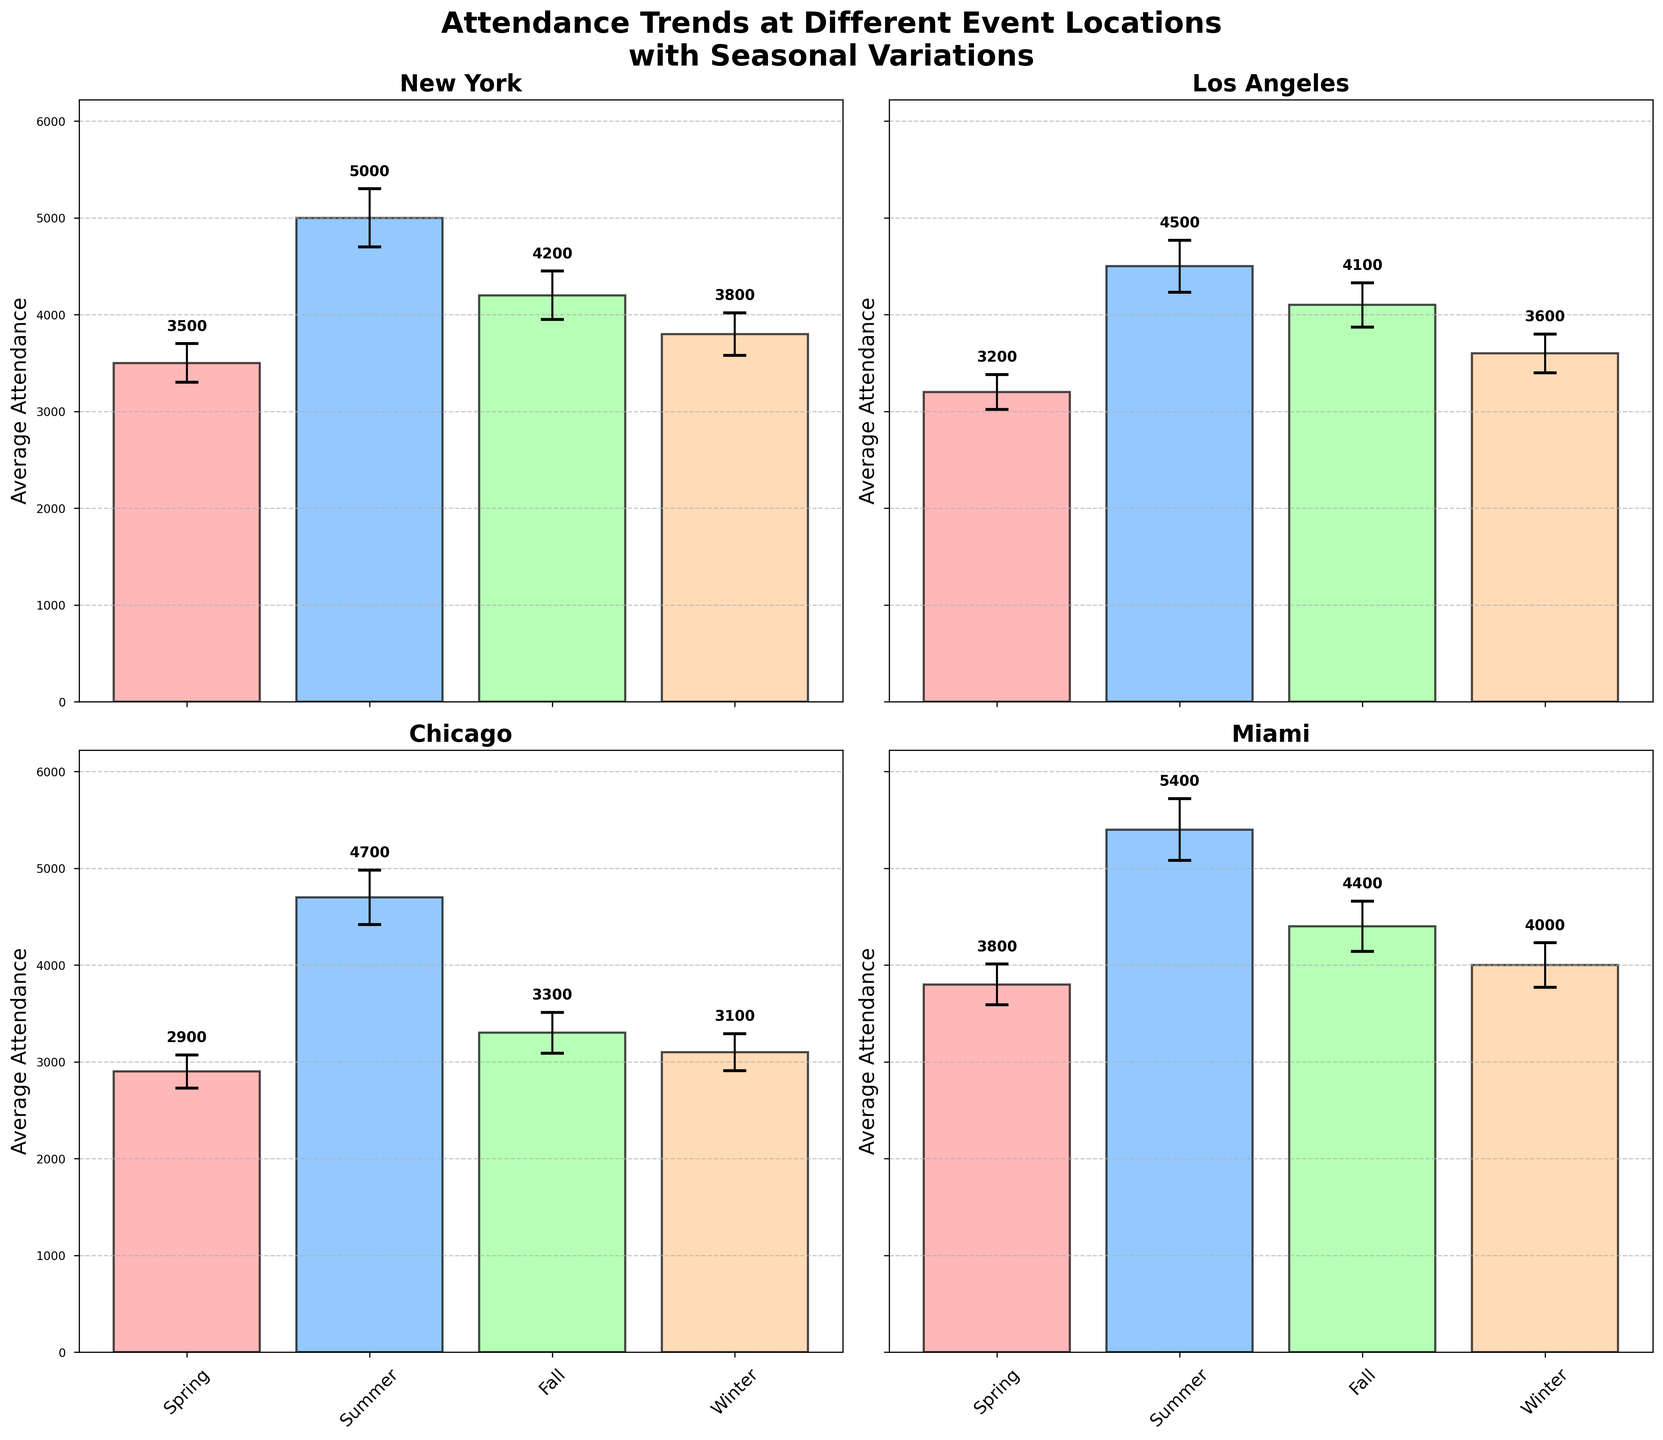What city's attendance is highest in Summer? By looking at the heights of the bars for the Summer season across all cities, Miami has the tallest bar, indicating the highest attendance.
Answer: Miami Which location has the lowest Winter attendance? Comparing the height of the Winter season bars across all subplots, Chicago has the shortest bar.
Answer: Chicago For New York, what is the difference in average attendance between Summer and Winter? The average attendance in Summer is 5000 and in Winter is 3800. The difference is 5000 - 3800 = 1200.
Answer: 1200 How do the error bars for New York in Fall compare with those for Miami in Spring? The error bar for New York in Fall has a standard deviation of 250, while the error bar for Miami in Spring has a standard deviation of 210. Therefore, New York in Fall has wider error bars than Miami in Spring.
Answer: Wider On average, which season generally sees the highest attendance across all cities? By observing the bar heights for each season across all subplots, Summer consistently has the highest bars on average.
Answer: Summer What is the total average attendance for Chicago across all seasons? Sum the average attendance values for Chicago across all seasons: 2900 (Spring) + 4700 (Summer) + 3300 (Fall) + 3100 (Winter) = 14000.
Answer: 14000 What is the range of attendance for Los Angeles in Summer, considering the error bars? The average attendance for Los Angeles in Summer is 4500 with a standard deviation of 270. Thus, the range is from 4500 - 270 to 4500 + 270, which is 4230 to 4770.
Answer: 4230 to 4770 Which city shows the most variation in attendance between different seasons? By visually comparing the differences in bar heights for each city's seasons, New York shows significant variation, especially between Spring and Summer, indicating the most variation.
Answer: New York Is the attendance in Miami for Fall higher or lower than in New York for the same season? The bar representing Fall for Miami is taller than that for New York, indicating Miami has a higher attendance in Fall.
Answer: Higher 